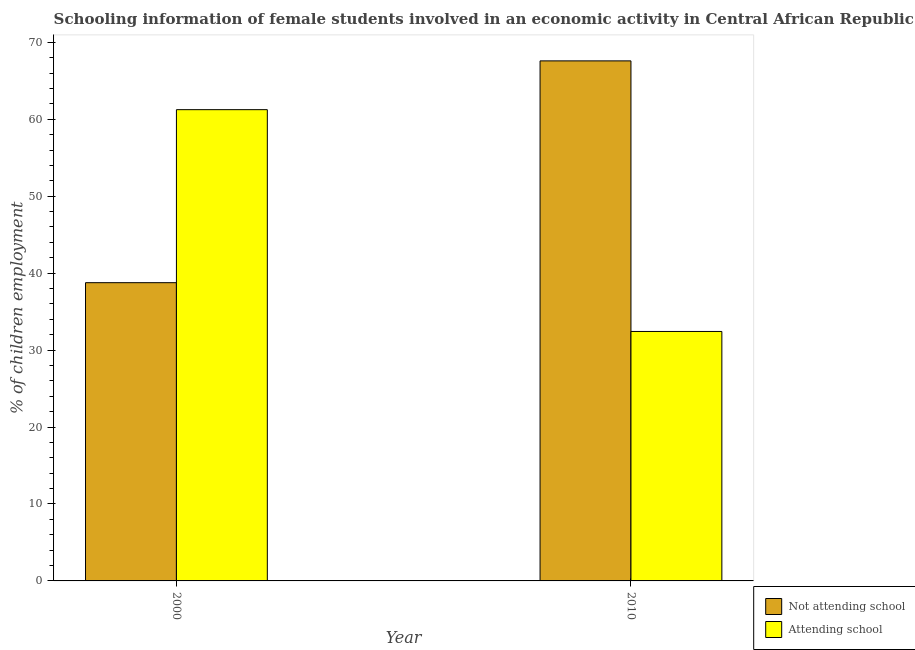How many bars are there on the 2nd tick from the left?
Provide a short and direct response. 2. In how many cases, is the number of bars for a given year not equal to the number of legend labels?
Your response must be concise. 0. What is the percentage of employed females who are not attending school in 2000?
Your response must be concise. 38.76. Across all years, what is the maximum percentage of employed females who are not attending school?
Your answer should be very brief. 67.58. Across all years, what is the minimum percentage of employed females who are not attending school?
Give a very brief answer. 38.76. What is the total percentage of employed females who are attending school in the graph?
Offer a terse response. 93.66. What is the difference between the percentage of employed females who are not attending school in 2000 and that in 2010?
Offer a terse response. -28.82. What is the difference between the percentage of employed females who are attending school in 2010 and the percentage of employed females who are not attending school in 2000?
Your response must be concise. -28.82. What is the average percentage of employed females who are attending school per year?
Make the answer very short. 46.83. What is the ratio of the percentage of employed females who are not attending school in 2000 to that in 2010?
Give a very brief answer. 0.57. Is the percentage of employed females who are attending school in 2000 less than that in 2010?
Your answer should be very brief. No. What does the 2nd bar from the left in 2010 represents?
Make the answer very short. Attending school. What does the 1st bar from the right in 2000 represents?
Provide a short and direct response. Attending school. Are all the bars in the graph horizontal?
Provide a succinct answer. No. How many years are there in the graph?
Give a very brief answer. 2. What is the difference between two consecutive major ticks on the Y-axis?
Your answer should be compact. 10. Are the values on the major ticks of Y-axis written in scientific E-notation?
Your answer should be very brief. No. What is the title of the graph?
Offer a very short reply. Schooling information of female students involved in an economic activity in Central African Republic. Does "Taxes" appear as one of the legend labels in the graph?
Ensure brevity in your answer.  No. What is the label or title of the Y-axis?
Provide a succinct answer. % of children employment. What is the % of children employment of Not attending school in 2000?
Keep it short and to the point. 38.76. What is the % of children employment of Attending school in 2000?
Make the answer very short. 61.24. What is the % of children employment of Not attending school in 2010?
Your answer should be compact. 67.58. What is the % of children employment in Attending school in 2010?
Provide a short and direct response. 32.42. Across all years, what is the maximum % of children employment in Not attending school?
Give a very brief answer. 67.58. Across all years, what is the maximum % of children employment of Attending school?
Make the answer very short. 61.24. Across all years, what is the minimum % of children employment of Not attending school?
Make the answer very short. 38.76. Across all years, what is the minimum % of children employment in Attending school?
Ensure brevity in your answer.  32.42. What is the total % of children employment in Not attending school in the graph?
Make the answer very short. 106.34. What is the total % of children employment in Attending school in the graph?
Your response must be concise. 93.66. What is the difference between the % of children employment of Not attending school in 2000 and that in 2010?
Offer a terse response. -28.82. What is the difference between the % of children employment of Attending school in 2000 and that in 2010?
Your answer should be compact. 28.82. What is the difference between the % of children employment of Not attending school in 2000 and the % of children employment of Attending school in 2010?
Your response must be concise. 6.34. What is the average % of children employment in Not attending school per year?
Give a very brief answer. 53.17. What is the average % of children employment in Attending school per year?
Your answer should be compact. 46.83. In the year 2000, what is the difference between the % of children employment in Not attending school and % of children employment in Attending school?
Offer a very short reply. -22.49. In the year 2010, what is the difference between the % of children employment of Not attending school and % of children employment of Attending school?
Your response must be concise. 35.16. What is the ratio of the % of children employment in Not attending school in 2000 to that in 2010?
Provide a short and direct response. 0.57. What is the ratio of the % of children employment of Attending school in 2000 to that in 2010?
Your response must be concise. 1.89. What is the difference between the highest and the second highest % of children employment of Not attending school?
Ensure brevity in your answer.  28.82. What is the difference between the highest and the second highest % of children employment of Attending school?
Keep it short and to the point. 28.82. What is the difference between the highest and the lowest % of children employment of Not attending school?
Your answer should be very brief. 28.82. What is the difference between the highest and the lowest % of children employment of Attending school?
Offer a very short reply. 28.82. 